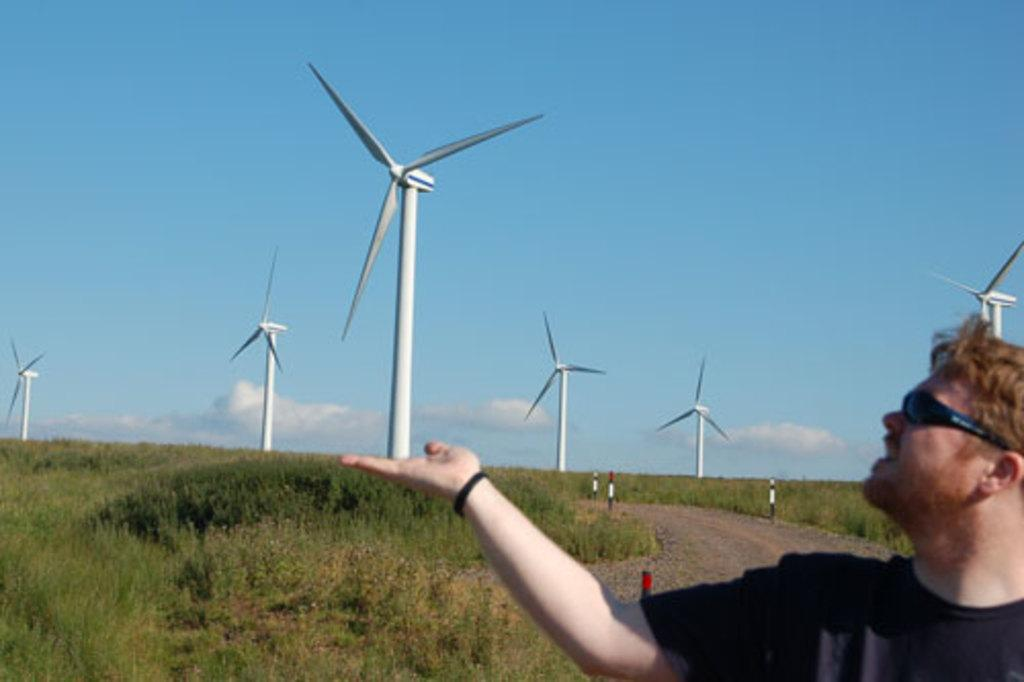Who is present in the image? There is a man in the image. What structures can be seen in the image? There are poles and windmills in the image. What type of vegetation is visible in the image? There is grass in the image. What can be seen in the background of the image? The sky is visible in the background of the image, and there are clouds in the sky. How does the man join the train in the image? There is no train present in the image, so the man cannot join one. 